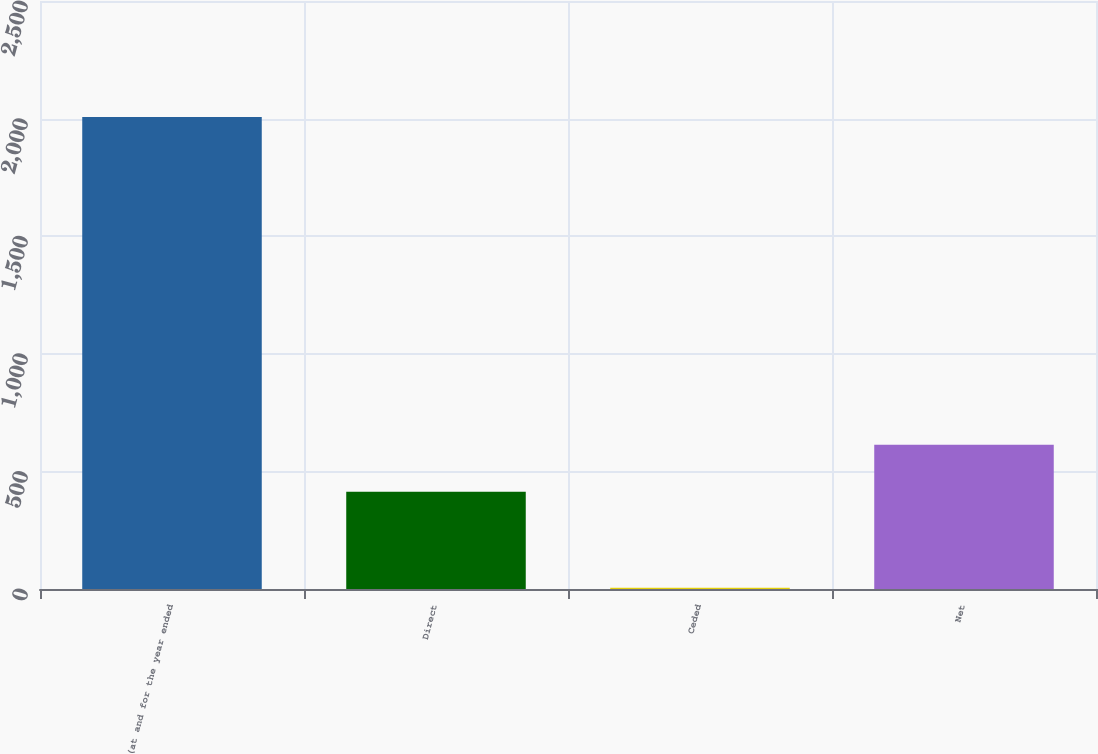Convert chart to OTSL. <chart><loc_0><loc_0><loc_500><loc_500><bar_chart><fcel>(at and for the year ended<fcel>Direct<fcel>Ceded<fcel>Net<nl><fcel>2007<fcel>413<fcel>5<fcel>613.2<nl></chart> 